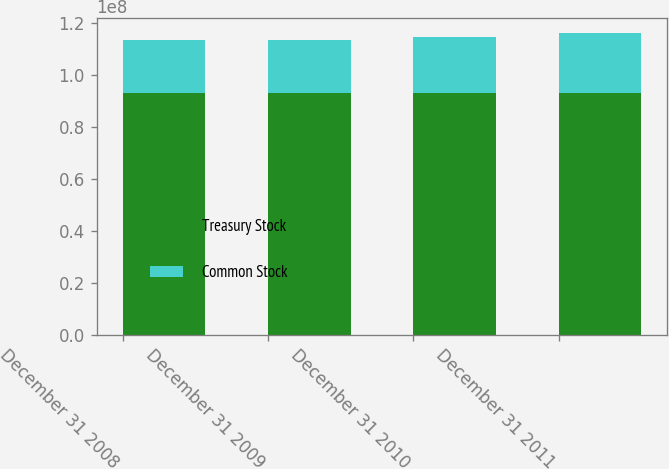<chart> <loc_0><loc_0><loc_500><loc_500><stacked_bar_chart><ecel><fcel>December 31 2008<fcel>December 31 2009<fcel>December 31 2010<fcel>December 31 2011<nl><fcel>Treasury Stock<fcel>9.29919e+07<fcel>9.29919e+07<fcel>9.29919e+07<fcel>9.29919e+07<nl><fcel>Common Stock<fcel>2.04819e+07<fcel>2.0473e+07<fcel>2.15061e+07<fcel>2.31547e+07<nl></chart> 